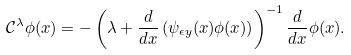Convert formula to latex. <formula><loc_0><loc_0><loc_500><loc_500>\mathcal { C } ^ { \lambda } \phi ( x ) = - \left ( \lambda + \frac { d } { d x } \left ( \psi _ { \epsilon y } ( x ) \phi ( x ) \right ) \right ) ^ { - 1 } \frac { d } { d x } \phi ( x ) .</formula> 